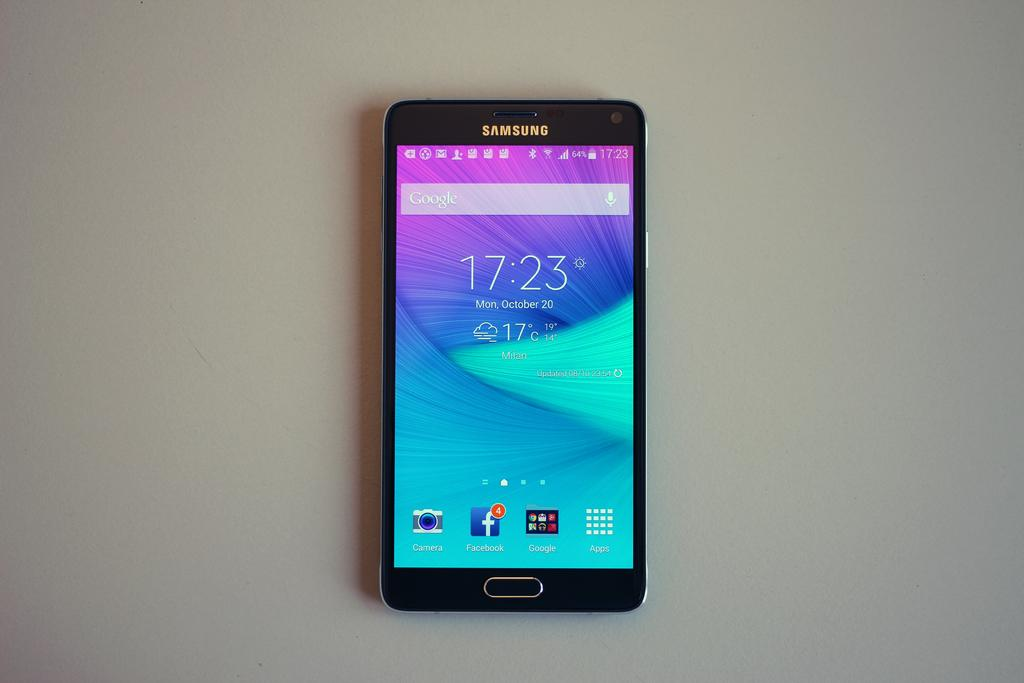Provide a one-sentence caption for the provided image. A Samsung phone turned on that says 17:23. 